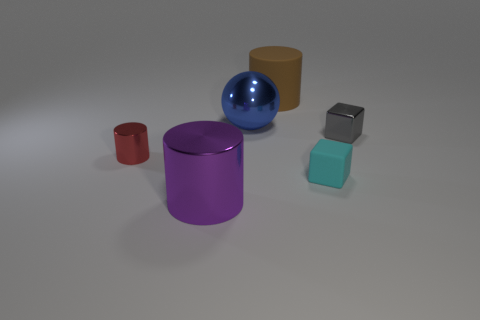Add 4 cyan things. How many objects exist? 10 Subtract all balls. How many objects are left? 5 Subtract all gray cylinders. Subtract all big brown rubber things. How many objects are left? 5 Add 5 blocks. How many blocks are left? 7 Add 4 small cyan matte blocks. How many small cyan matte blocks exist? 5 Subtract 1 brown cylinders. How many objects are left? 5 